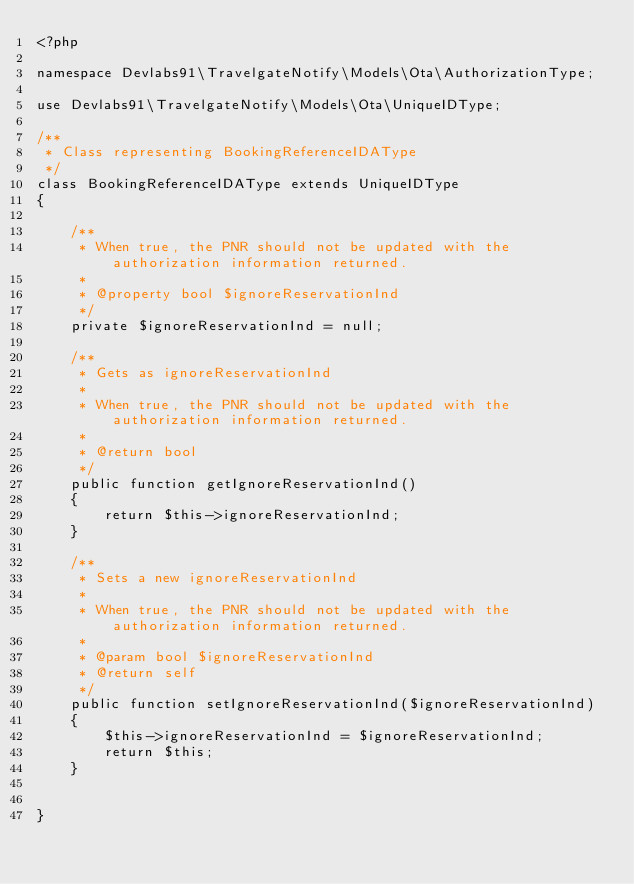<code> <loc_0><loc_0><loc_500><loc_500><_PHP_><?php

namespace Devlabs91\TravelgateNotify\Models\Ota\AuthorizationType;

use Devlabs91\TravelgateNotify\Models\Ota\UniqueIDType;

/**
 * Class representing BookingReferenceIDAType
 */
class BookingReferenceIDAType extends UniqueIDType
{

    /**
     * When true, the PNR should not be updated with the authorization information returned.
     *
     * @property bool $ignoreReservationInd
     */
    private $ignoreReservationInd = null;

    /**
     * Gets as ignoreReservationInd
     *
     * When true, the PNR should not be updated with the authorization information returned.
     *
     * @return bool
     */
    public function getIgnoreReservationInd()
    {
        return $this->ignoreReservationInd;
    }

    /**
     * Sets a new ignoreReservationInd
     *
     * When true, the PNR should not be updated with the authorization information returned.
     *
     * @param bool $ignoreReservationInd
     * @return self
     */
    public function setIgnoreReservationInd($ignoreReservationInd)
    {
        $this->ignoreReservationInd = $ignoreReservationInd;
        return $this;
    }


}

</code> 